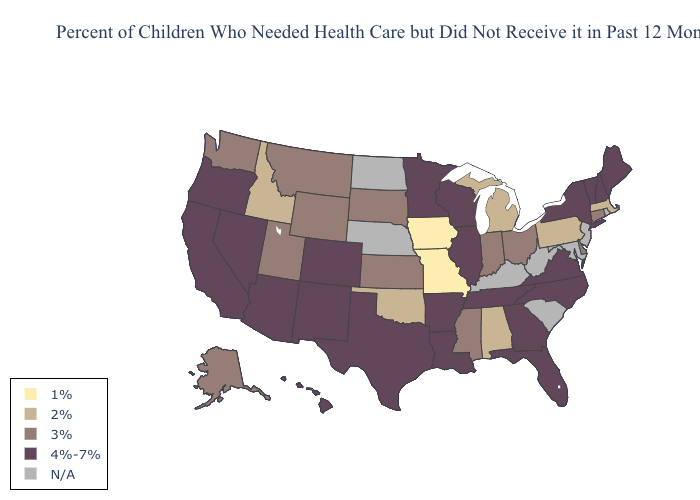Among the states that border Arizona , does Utah have the highest value?
Be succinct. No. Does Oklahoma have the highest value in the USA?
Concise answer only. No. Name the states that have a value in the range 4%-7%?
Concise answer only. Arizona, Arkansas, California, Colorado, Florida, Georgia, Hawaii, Illinois, Louisiana, Maine, Minnesota, Nevada, New Hampshire, New Mexico, New York, North Carolina, Oregon, Tennessee, Texas, Vermont, Virginia, Wisconsin. Name the states that have a value in the range N/A?
Keep it brief. Kentucky, Maryland, Nebraska, New Jersey, North Dakota, Rhode Island, South Carolina, West Virginia. What is the value of Virginia?
Concise answer only. 4%-7%. What is the value of Kansas?
Write a very short answer. 3%. Which states hav the highest value in the MidWest?
Keep it brief. Illinois, Minnesota, Wisconsin. Name the states that have a value in the range 1%?
Concise answer only. Iowa, Missouri. Among the states that border South Dakota , does Minnesota have the lowest value?
Keep it brief. No. Name the states that have a value in the range 1%?
Be succinct. Iowa, Missouri. Among the states that border Illinois , does Missouri have the lowest value?
Answer briefly. Yes. Does the map have missing data?
Quick response, please. Yes. What is the value of Missouri?
Concise answer only. 1%. How many symbols are there in the legend?
Give a very brief answer. 5. 